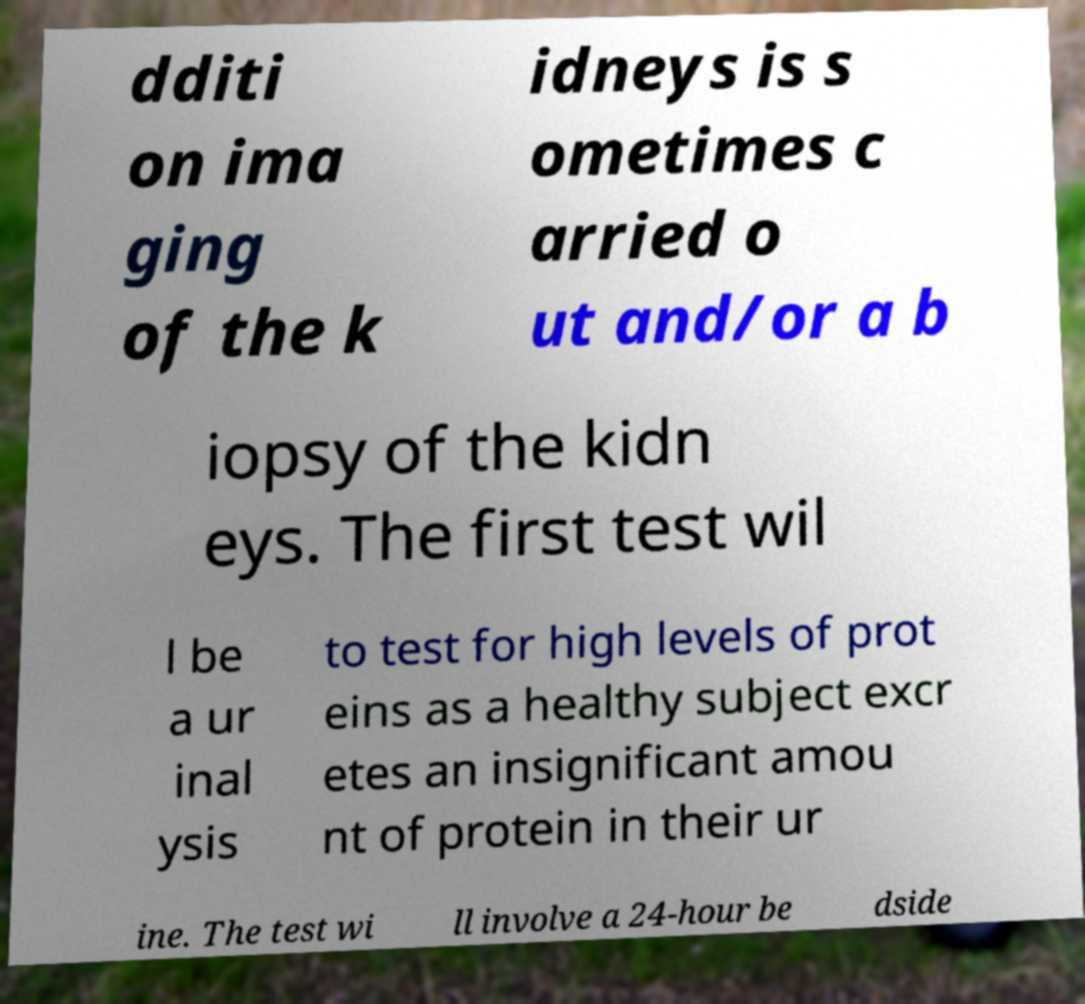There's text embedded in this image that I need extracted. Can you transcribe it verbatim? dditi on ima ging of the k idneys is s ometimes c arried o ut and/or a b iopsy of the kidn eys. The first test wil l be a ur inal ysis to test for high levels of prot eins as a healthy subject excr etes an insignificant amou nt of protein in their ur ine. The test wi ll involve a 24-hour be dside 